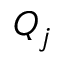<formula> <loc_0><loc_0><loc_500><loc_500>Q _ { j }</formula> 